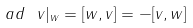Convert formula to latex. <formula><loc_0><loc_0><loc_500><loc_500>a d \ v | _ { w } = [ w , v ] = - [ v , w ]</formula> 